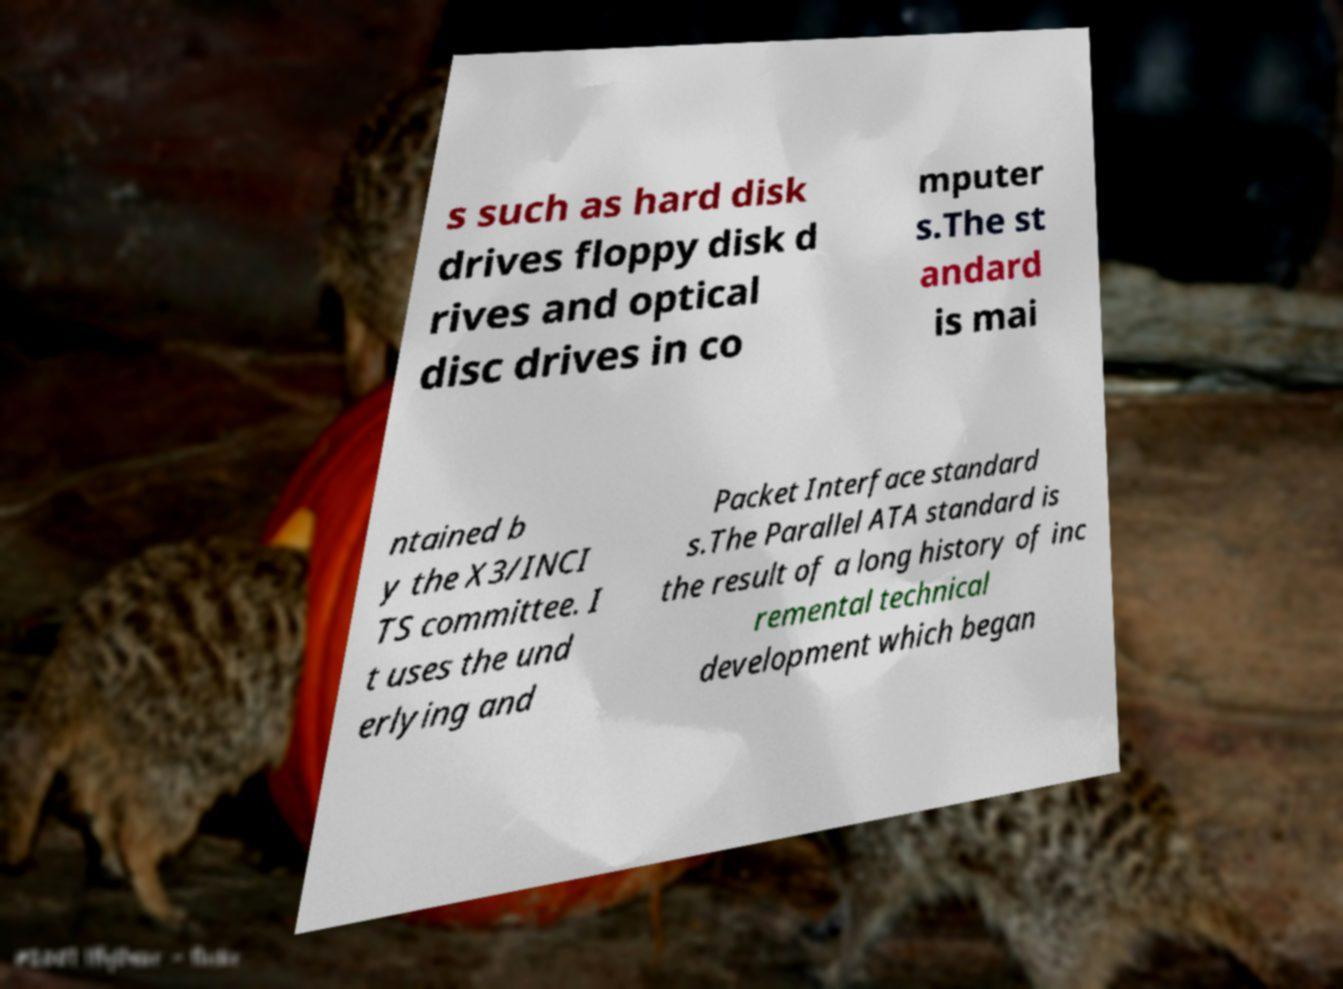Please identify and transcribe the text found in this image. s such as hard disk drives floppy disk d rives and optical disc drives in co mputer s.The st andard is mai ntained b y the X3/INCI TS committee. I t uses the und erlying and Packet Interface standard s.The Parallel ATA standard is the result of a long history of inc remental technical development which began 